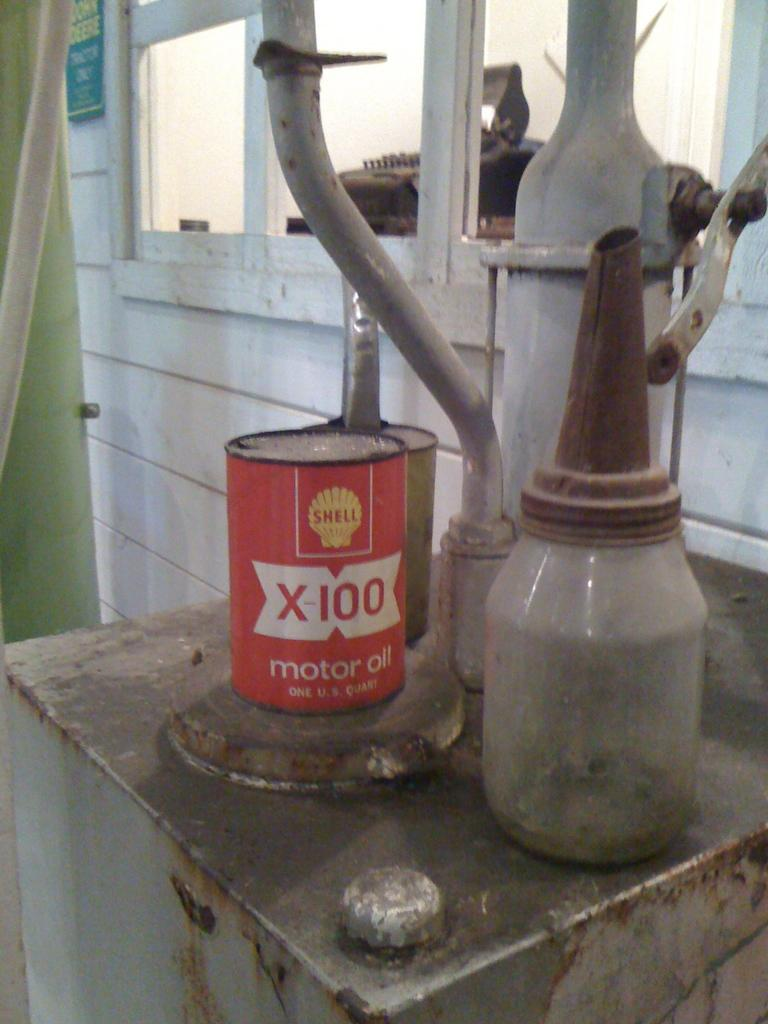<image>
Create a compact narrative representing the image presented. A one U.S. quart can of Shell X-100 motor oil is on the rusty table. 